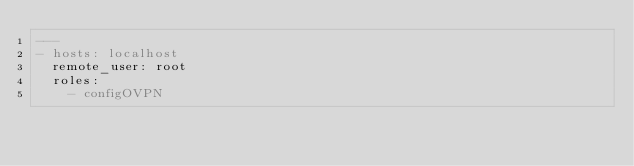Convert code to text. <code><loc_0><loc_0><loc_500><loc_500><_YAML_>---
- hosts: localhost
  remote_user: root
  roles:
    - configOVPN</code> 